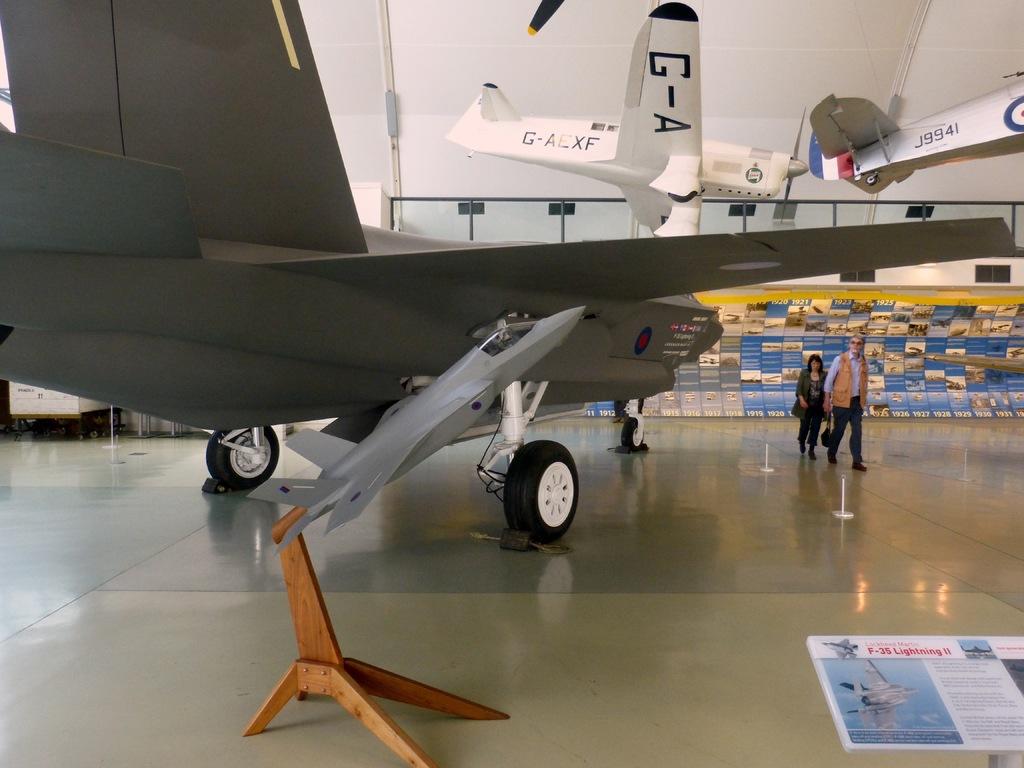What is the type of plane?
Provide a short and direct response. F-35 lightning ii. What identification is on the silver plane?
Give a very brief answer. G-a. 